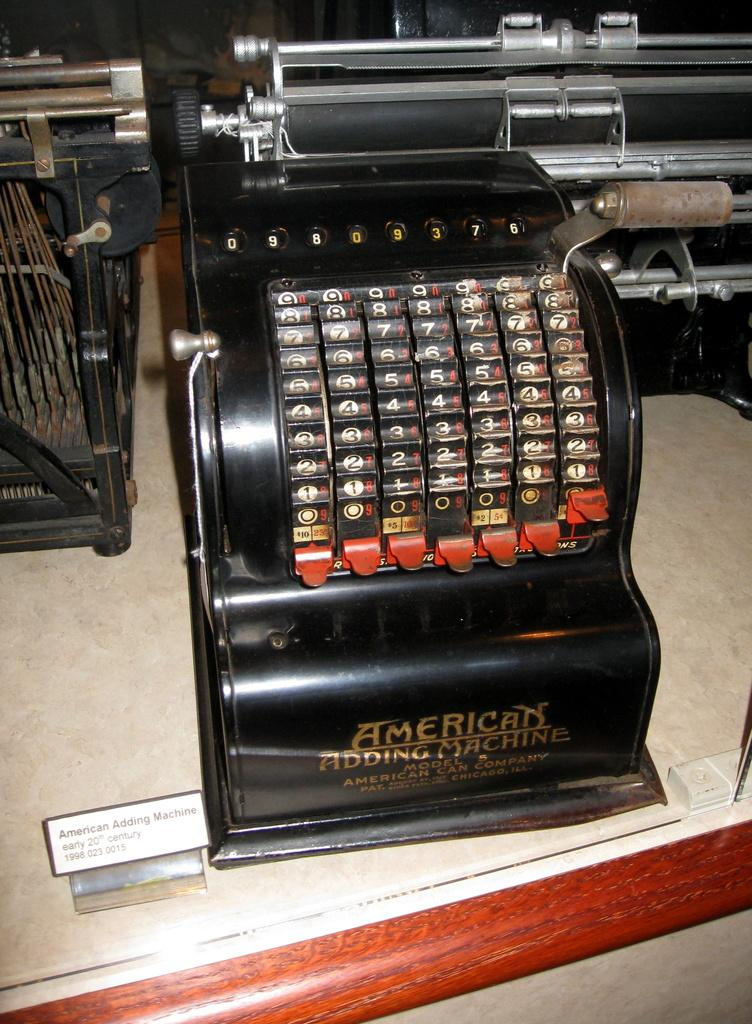What type of machine is the main subject in the image? There is an adding machine in the image. What else can be seen on the table in the image? There are other machines on a table in the image. Is there any text visible in the image? Yes, there is a card with text written on it in the image. What type of birth is depicted in the image? There is no birth depicted in the image; it features an adding machine and other machines on a table. Can you tell me who the parent is in the image? There is no parent or child present in the image; it focuses on machines and a card with text. 